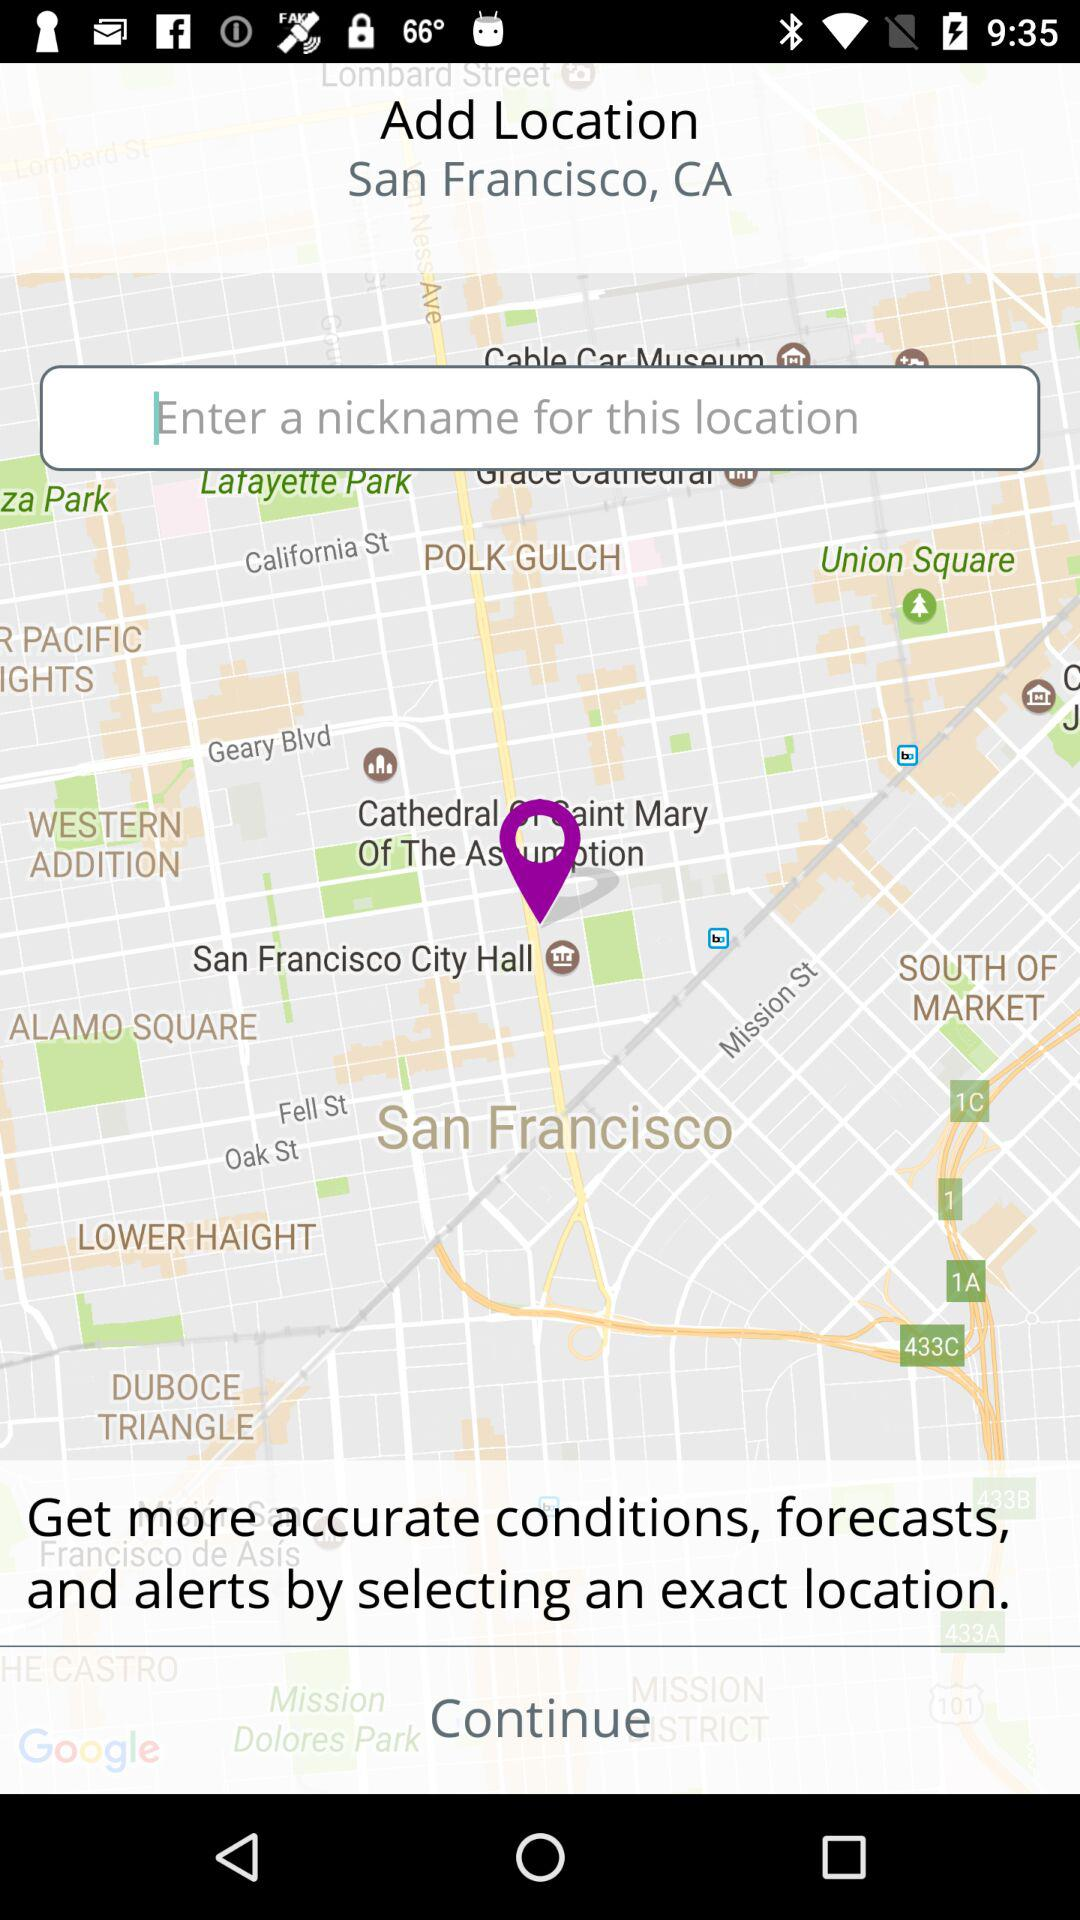Which place's name is given on the screen?
When the provided information is insufficient, respond with <no answer>. <no answer> 